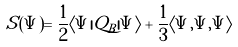Convert formula to latex. <formula><loc_0><loc_0><loc_500><loc_500>S ( \Psi ) = { \frac { 1 } { 2 } } \langle \Psi | Q _ { B } | \Psi \rangle + { \frac { 1 } { 3 } } \langle \Psi , \Psi , \Psi \rangle</formula> 